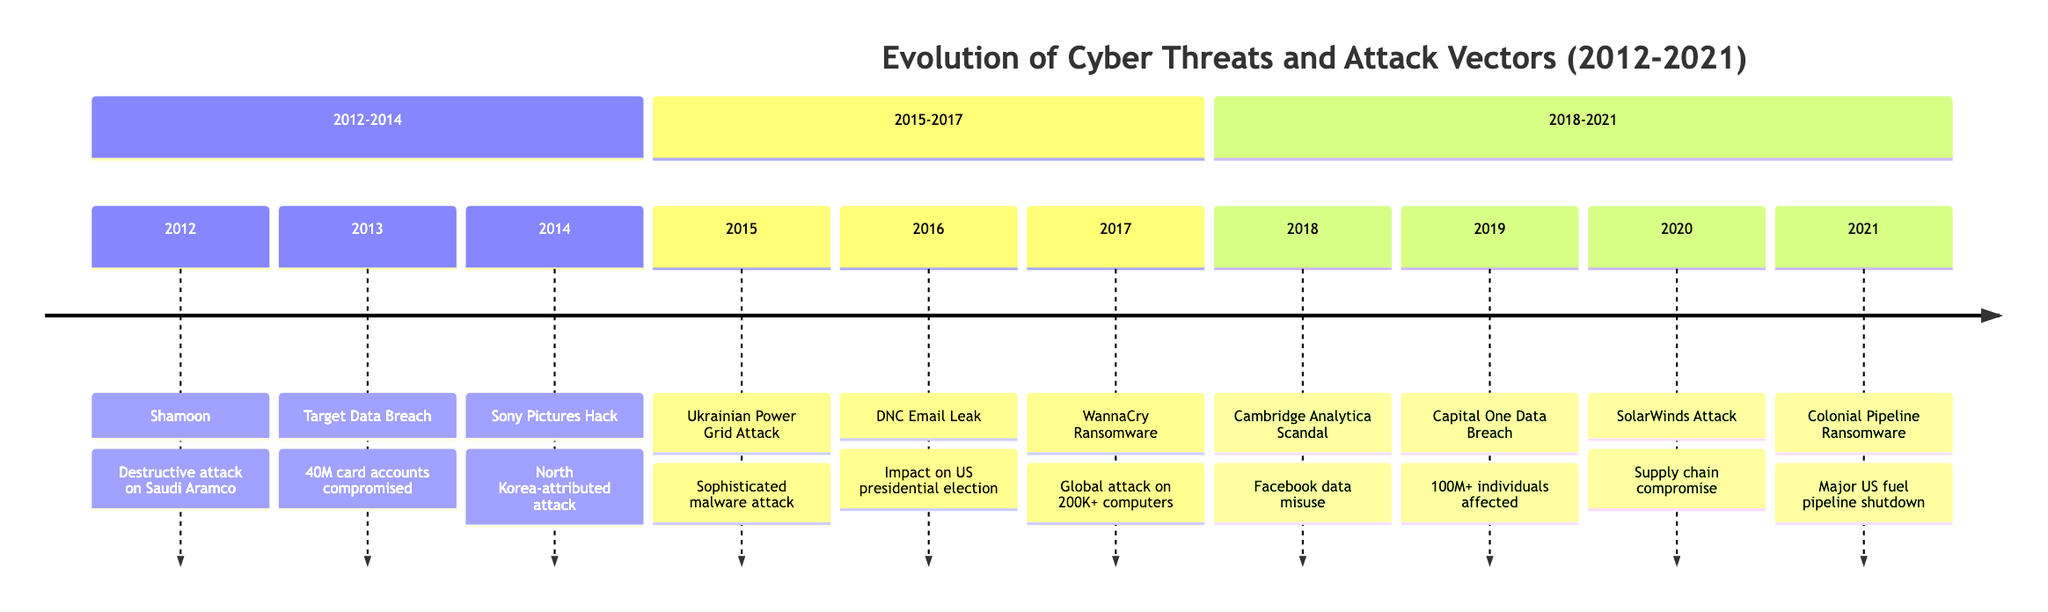What significant event occurred in 2012? The diagram shows "Shamoon" as the event for the year 2012, indicating a destructive attack on Saudi Aramco.
Answer: Shamoon How many major incidents are listed between 2012 and 2014? By examining the timeline, we see three distinct events: Shamoon (2012), Target Data Breach (2013), and Sony Pictures Hack (2014).
Answer: 3 Which attack is attributed to North Korea? In the timeline, the "Sony Pictures Hack" in 2014 is specifically labeled as being attributed to North Korea.
Answer: Sony Pictures Hack What year did the WannaCry ransomware attack occur? The timeline indicates that the WannaCry Ransomware attack took place in 2017, clearly marking it under that year.
Answer: 2017 Which incident involved a supply chain attack? The timeline mentions the "SolarWinds Attack" in 2020, which is described as a supply chain attack that compromised multiple organizations.
Answer: SolarWinds Attack Between 2015 and 2017, what type of attack affected the power grid? The timeline specifies "Ukrainian Power Grid Attack" in 2015, describing it as a sophisticated malware attack affecting the power grid.
Answer: Malware attack How many individuals were affected by the Capital One Data Breach in 2019? The timeline explicitly states that the Capital One Data Breach in 2019 exposed personal information of over 100 million individuals.
Answer: 100 million What was the impact of the DNC Email Leak in 2016? The timeline indicates that the DNC Email Leak impacted the US presidential election, highlighting its significance during that year.
Answer: Impact on US presidential election In which year did the Colonial Pipeline ransomware attack occur? The timeline clearly points to the year 2021 as the occurrence of the Colonial Pipeline ransomware attack.
Answer: 2021 